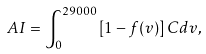<formula> <loc_0><loc_0><loc_500><loc_500>A I = \int _ { 0 } ^ { 2 9 0 0 0 } \left [ 1 - f ( v ) \right ] C d v ,</formula> 